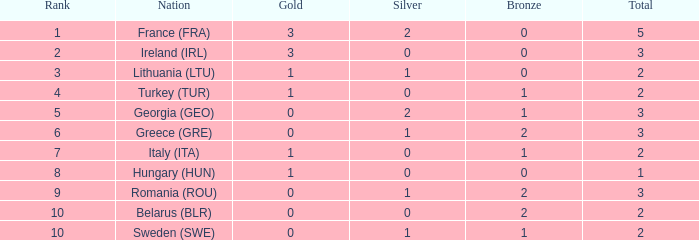What are the most bronze medals in a rank more than 1 with a total larger than 3? None. 